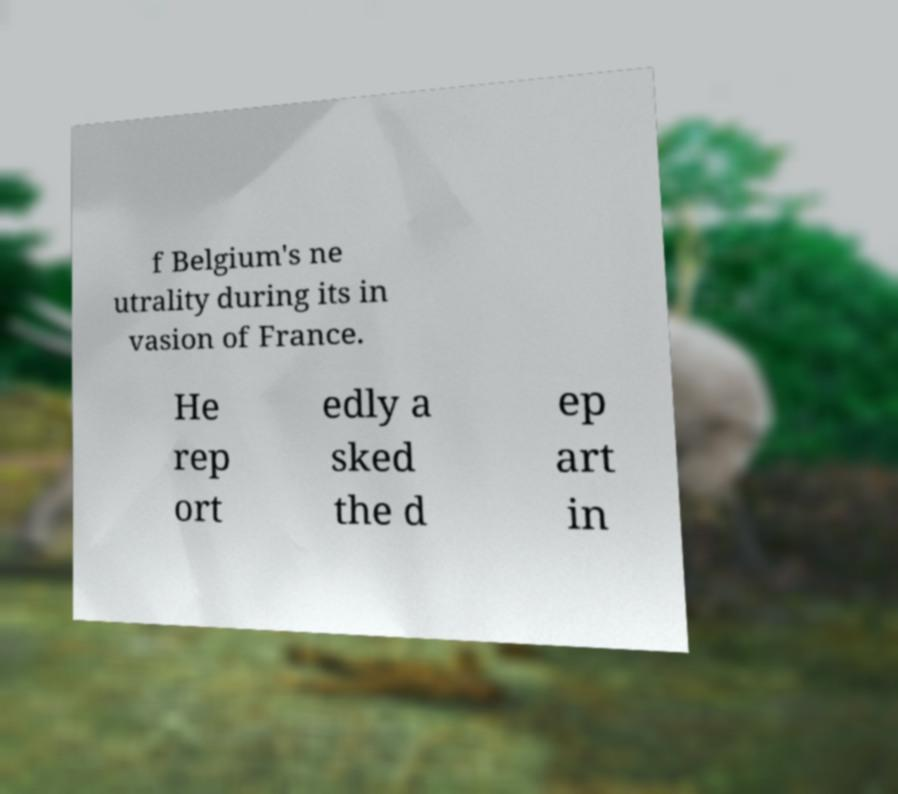Can you accurately transcribe the text from the provided image for me? f Belgium's ne utrality during its in vasion of France. He rep ort edly a sked the d ep art in 